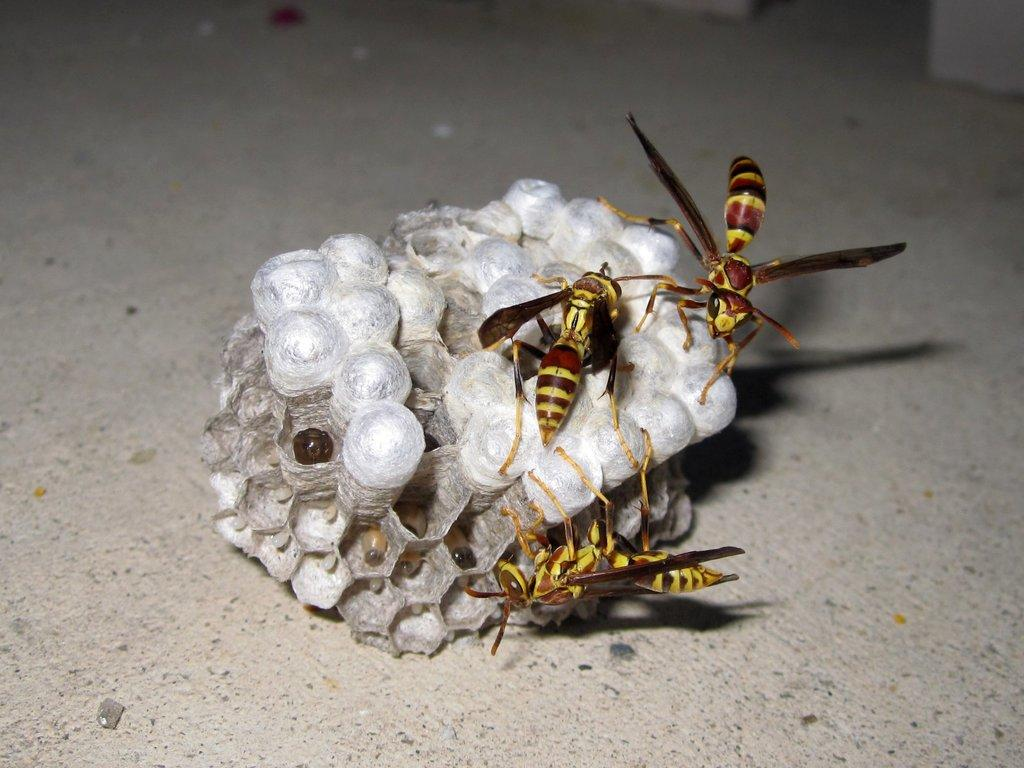What is the main subject in the image? There is a honeycomb in the image. Where is the honeycomb located? The honeycomb is on the floor. How many honey bees can be seen on the honeycomb? There are three honey bees on the honeycomb. What type of balloon can be seen floating above the honeycomb in the image? There is no balloon present in the image; it only features a honeycomb and honey bees. What is the honeycomb doing to cause trouble in the image? The honeycomb is not causing any trouble in the image; it is simply on the floor with honey bees on it. 